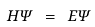Convert formula to latex. <formula><loc_0><loc_0><loc_500><loc_500>H \Psi \ = \ E \Psi</formula> 